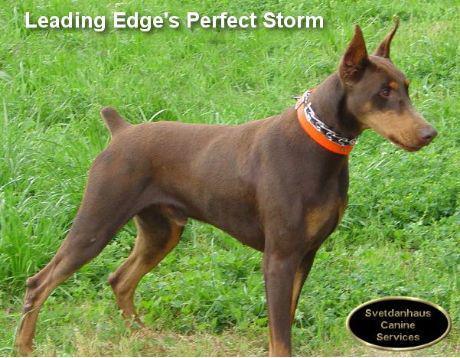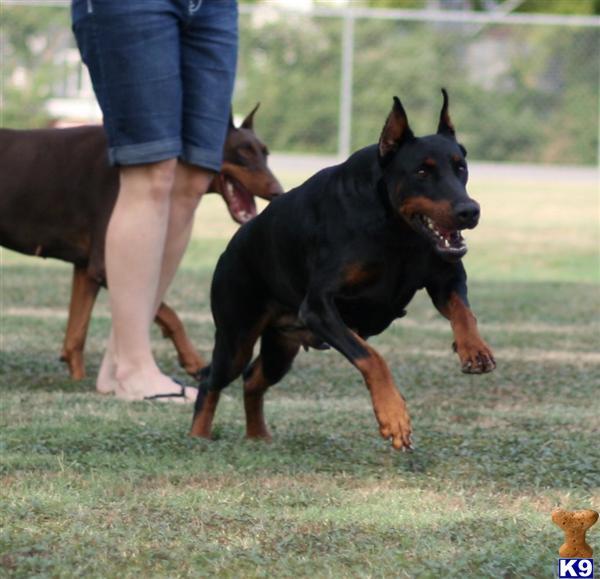The first image is the image on the left, the second image is the image on the right. Evaluate the accuracy of this statement regarding the images: "One dog stands alone in the image on the left, and the right image shows a person standing by at least one doberman.". Is it true? Answer yes or no. Yes. The first image is the image on the left, the second image is the image on the right. Examine the images to the left and right. Is the description "there are two dogs side by side , at least one dog has dog tags on it's collar" accurate? Answer yes or no. No. 